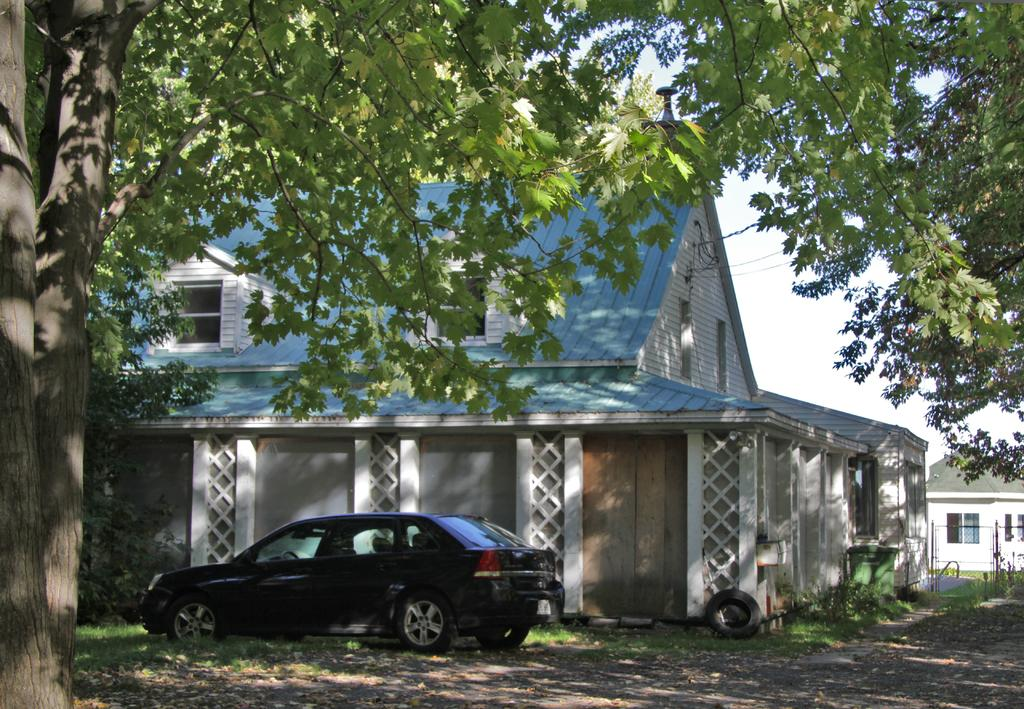What type of vehicle is located on the left side of the image? There is a car on the left side of the image. What structures are in the middle of the image? There are houses in the middle of the image. What type of vegetation is on either side of the image? There are trees on either side of the image. What is visible at the top of the image? The sky is visible at the top of the image. How many vans are parked on the road in the image? There is no road or van present in the image; it features a car, houses, trees, and a sky. What type of fowl can be seen walking on the grass in the image? There is no fowl present in the image; it features a car, houses, trees, and a sky. 